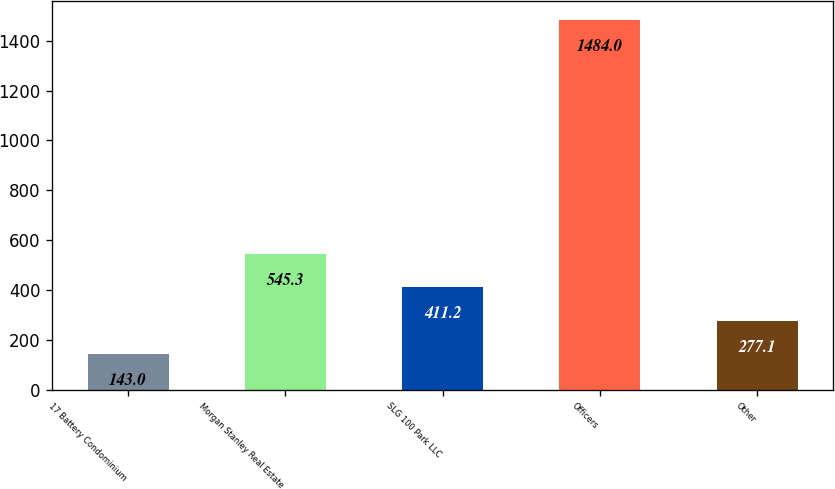Convert chart to OTSL. <chart><loc_0><loc_0><loc_500><loc_500><bar_chart><fcel>17 Battery Condominium<fcel>Morgan Stanley Real Estate<fcel>SLG 100 Park LLC<fcel>Officers<fcel>Other<nl><fcel>143<fcel>545.3<fcel>411.2<fcel>1484<fcel>277.1<nl></chart> 